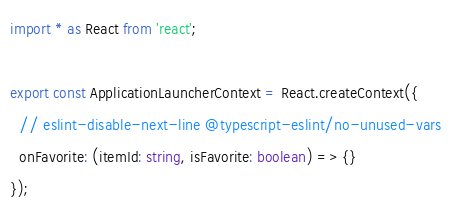<code> <loc_0><loc_0><loc_500><loc_500><_TypeScript_>import * as React from 'react';

export const ApplicationLauncherContext = React.createContext({
  // eslint-disable-next-line @typescript-eslint/no-unused-vars
  onFavorite: (itemId: string, isFavorite: boolean) => {}
});
</code> 